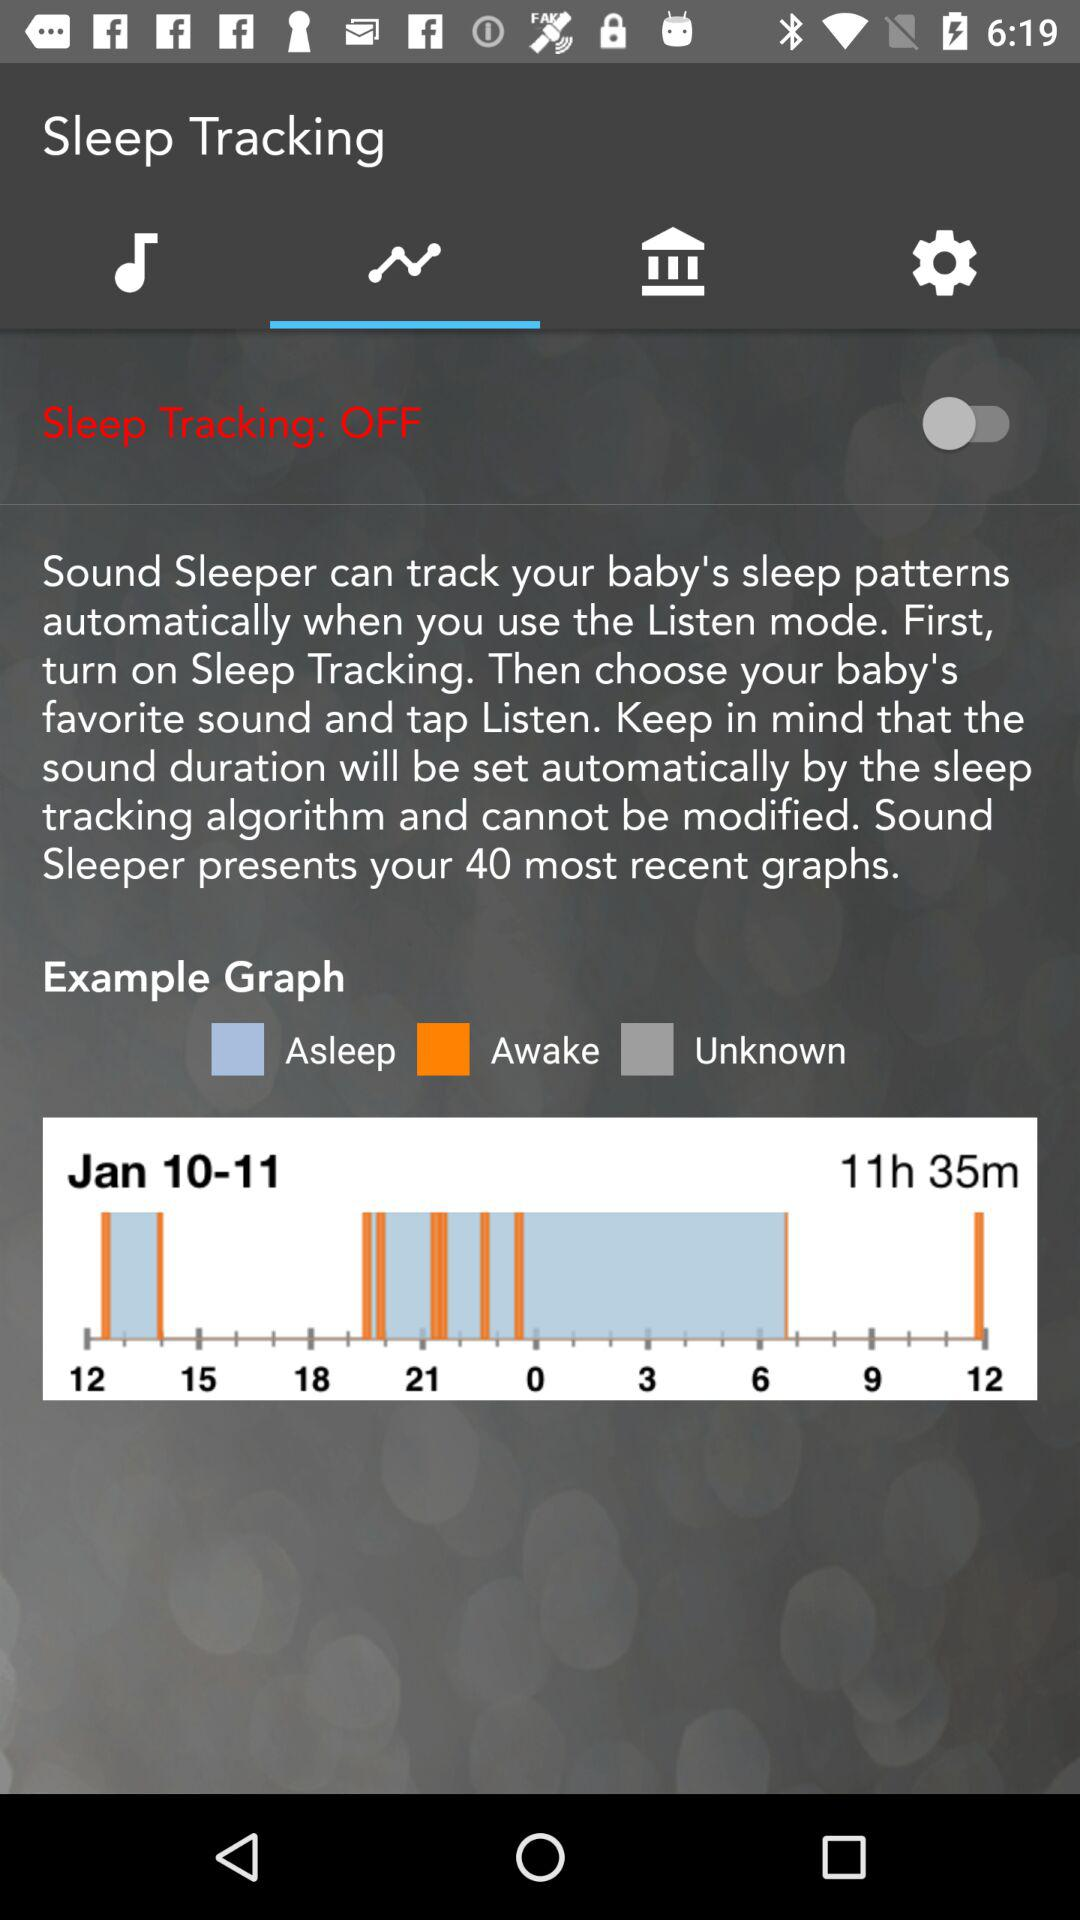What are the different parameters used in the graph? The different parameters used in the graphs are "Asleep", "Awake" and "Unknown". 